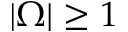Convert formula to latex. <formula><loc_0><loc_0><loc_500><loc_500>| \Omega | \geq 1</formula> 